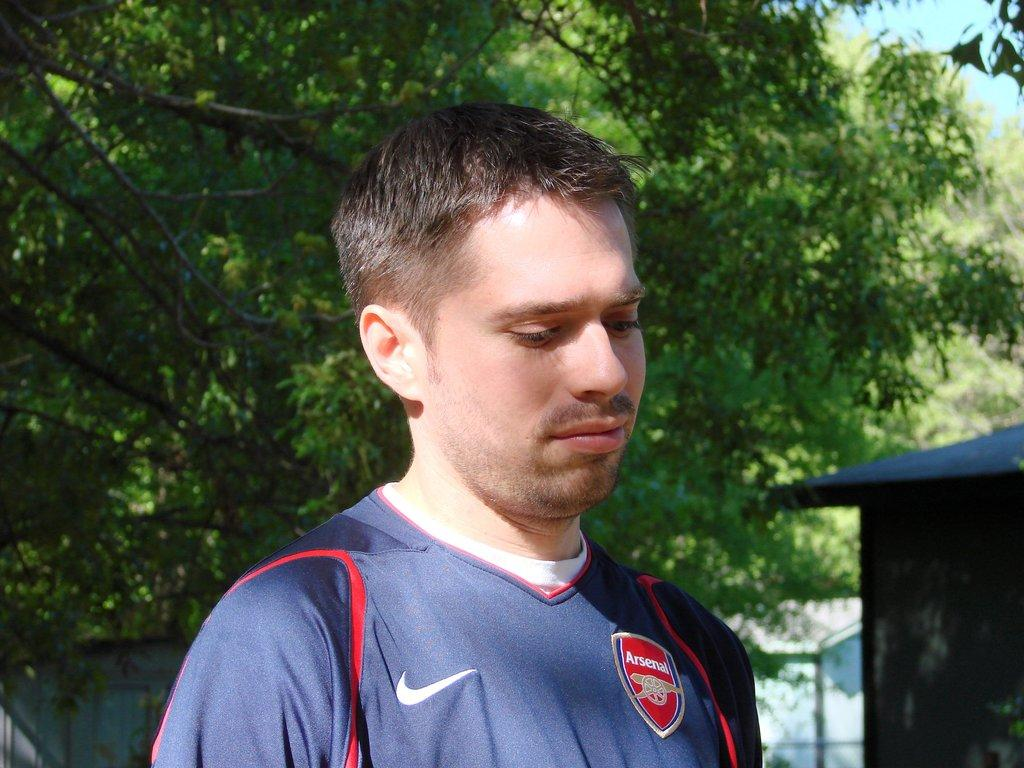What can be seen in the image? There is a person in the image. What is the person wearing? The person is wearing a dark blue T-shirt. How would you describe the background of the image? The background of the image is slightly blurred. What type of natural scenery is visible in the background? There are trees in the background of the image. What else can be seen in the background? There is a house and the sky visible in the background of the image. What songs is the person singing in the image? There is no indication in the image that the person is singing any songs. Can you see a turkey in the image? No, there is no turkey present in the image. 